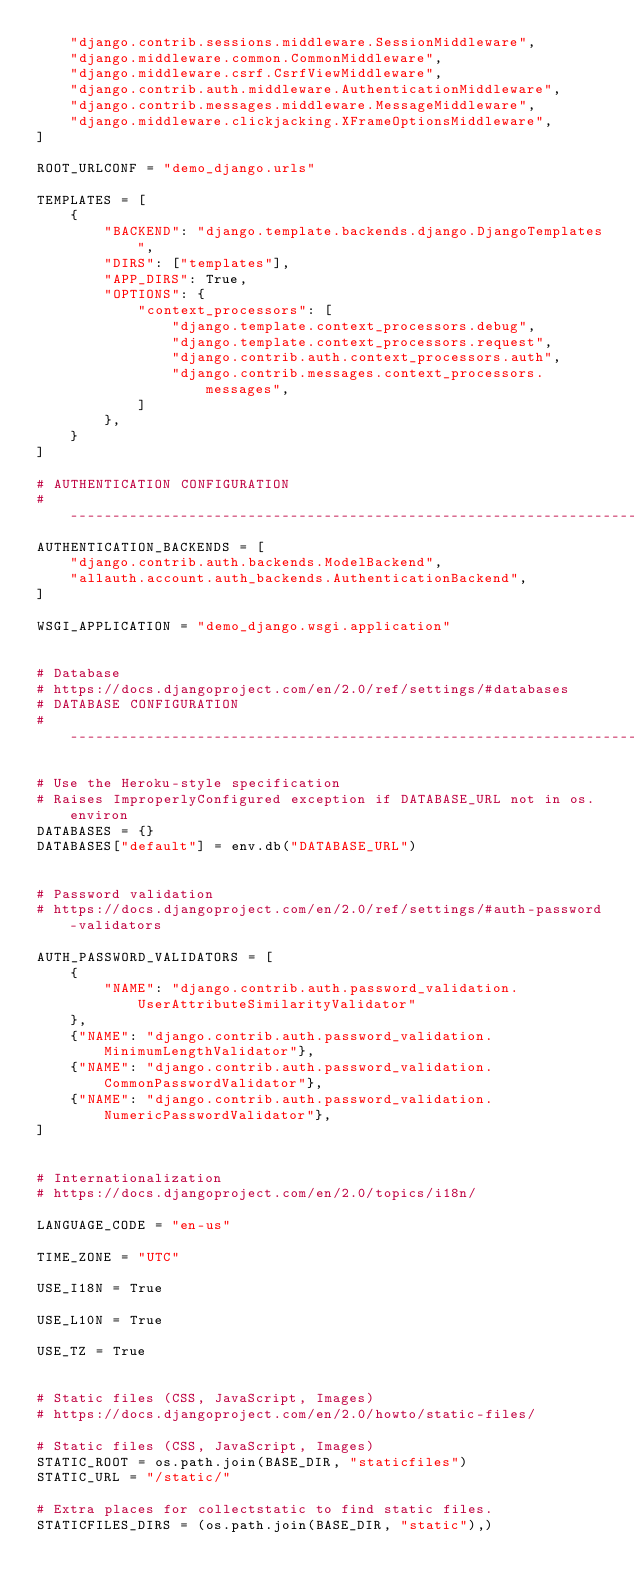Convert code to text. <code><loc_0><loc_0><loc_500><loc_500><_Python_>    "django.contrib.sessions.middleware.SessionMiddleware",
    "django.middleware.common.CommonMiddleware",
    "django.middleware.csrf.CsrfViewMiddleware",
    "django.contrib.auth.middleware.AuthenticationMiddleware",
    "django.contrib.messages.middleware.MessageMiddleware",
    "django.middleware.clickjacking.XFrameOptionsMiddleware",
]

ROOT_URLCONF = "demo_django.urls"

TEMPLATES = [
    {
        "BACKEND": "django.template.backends.django.DjangoTemplates",
        "DIRS": ["templates"],
        "APP_DIRS": True,
        "OPTIONS": {
            "context_processors": [
                "django.template.context_processors.debug",
                "django.template.context_processors.request",
                "django.contrib.auth.context_processors.auth",
                "django.contrib.messages.context_processors.messages",
            ]
        },
    }
]

# AUTHENTICATION CONFIGURATION
# ------------------------------------------------------------------------------
AUTHENTICATION_BACKENDS = [
    "django.contrib.auth.backends.ModelBackend",
    "allauth.account.auth_backends.AuthenticationBackend",
]

WSGI_APPLICATION = "demo_django.wsgi.application"


# Database
# https://docs.djangoproject.com/en/2.0/ref/settings/#databases
# DATABASE CONFIGURATION
# ------------------------------------------------------------------------------

# Use the Heroku-style specification
# Raises ImproperlyConfigured exception if DATABASE_URL not in os.environ
DATABASES = {}
DATABASES["default"] = env.db("DATABASE_URL")


# Password validation
# https://docs.djangoproject.com/en/2.0/ref/settings/#auth-password-validators

AUTH_PASSWORD_VALIDATORS = [
    {
        "NAME": "django.contrib.auth.password_validation.UserAttributeSimilarityValidator"
    },
    {"NAME": "django.contrib.auth.password_validation.MinimumLengthValidator"},
    {"NAME": "django.contrib.auth.password_validation.CommonPasswordValidator"},
    {"NAME": "django.contrib.auth.password_validation.NumericPasswordValidator"},
]


# Internationalization
# https://docs.djangoproject.com/en/2.0/topics/i18n/

LANGUAGE_CODE = "en-us"

TIME_ZONE = "UTC"

USE_I18N = True

USE_L10N = True

USE_TZ = True


# Static files (CSS, JavaScript, Images)
# https://docs.djangoproject.com/en/2.0/howto/static-files/

# Static files (CSS, JavaScript, Images)
STATIC_ROOT = os.path.join(BASE_DIR, "staticfiles")
STATIC_URL = "/static/"

# Extra places for collectstatic to find static files.
STATICFILES_DIRS = (os.path.join(BASE_DIR, "static"),)
</code> 